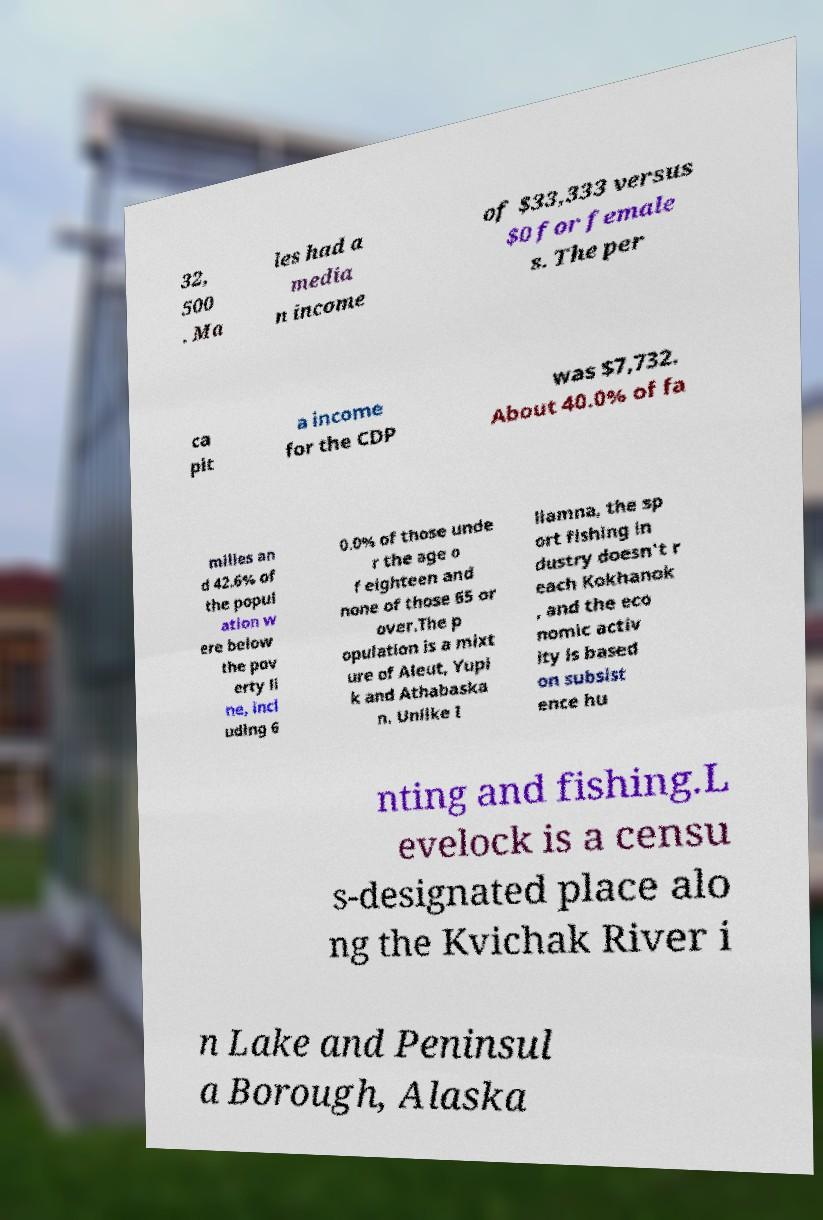Could you assist in decoding the text presented in this image and type it out clearly? 32, 500 . Ma les had a media n income of $33,333 versus $0 for female s. The per ca pit a income for the CDP was $7,732. About 40.0% of fa milies an d 42.6% of the popul ation w ere below the pov erty li ne, incl uding 6 0.0% of those unde r the age o f eighteen and none of those 65 or over.The p opulation is a mixt ure of Aleut, Yupi k and Athabaska n. Unlike I liamna, the sp ort fishing in dustry doesn't r each Kokhanok , and the eco nomic activ ity is based on subsist ence hu nting and fishing.L evelock is a censu s-designated place alo ng the Kvichak River i n Lake and Peninsul a Borough, Alaska 